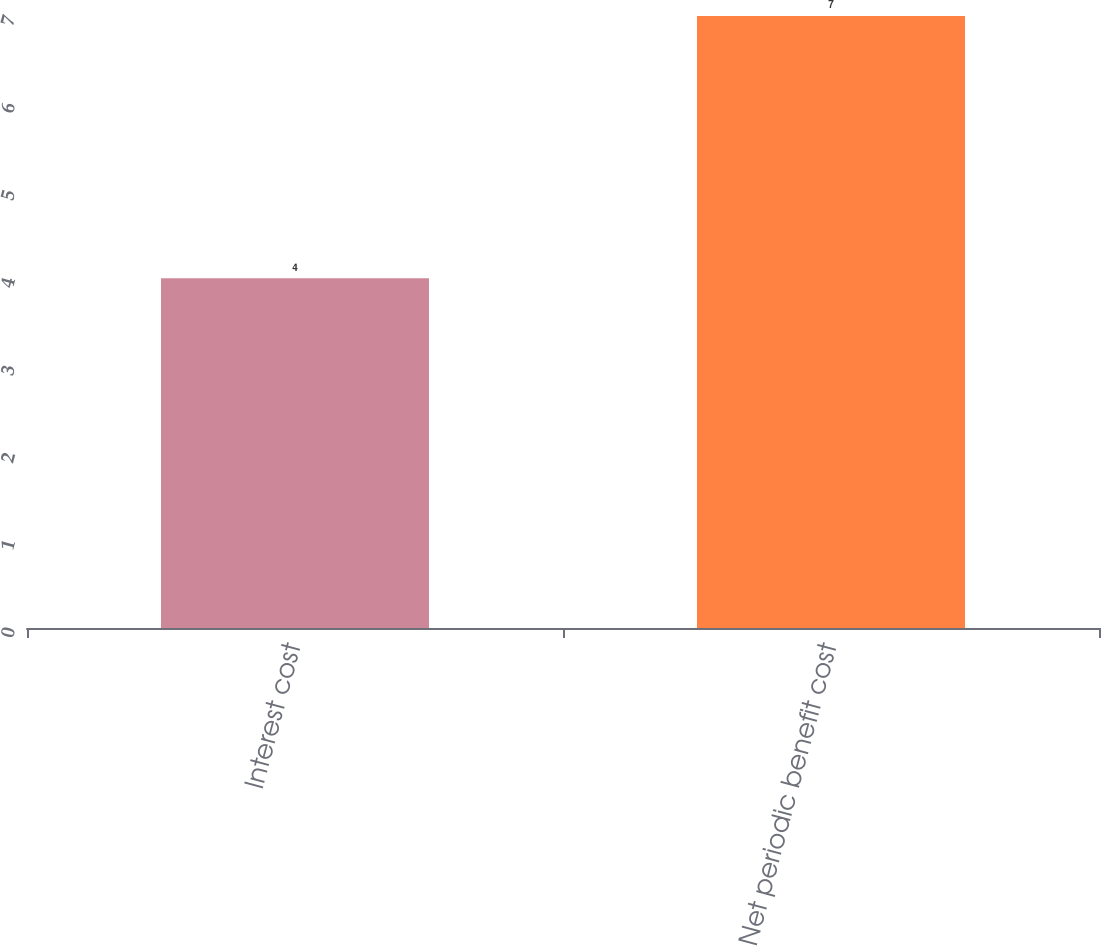Convert chart to OTSL. <chart><loc_0><loc_0><loc_500><loc_500><bar_chart><fcel>Interest cost<fcel>Net periodic benefit cost<nl><fcel>4<fcel>7<nl></chart> 